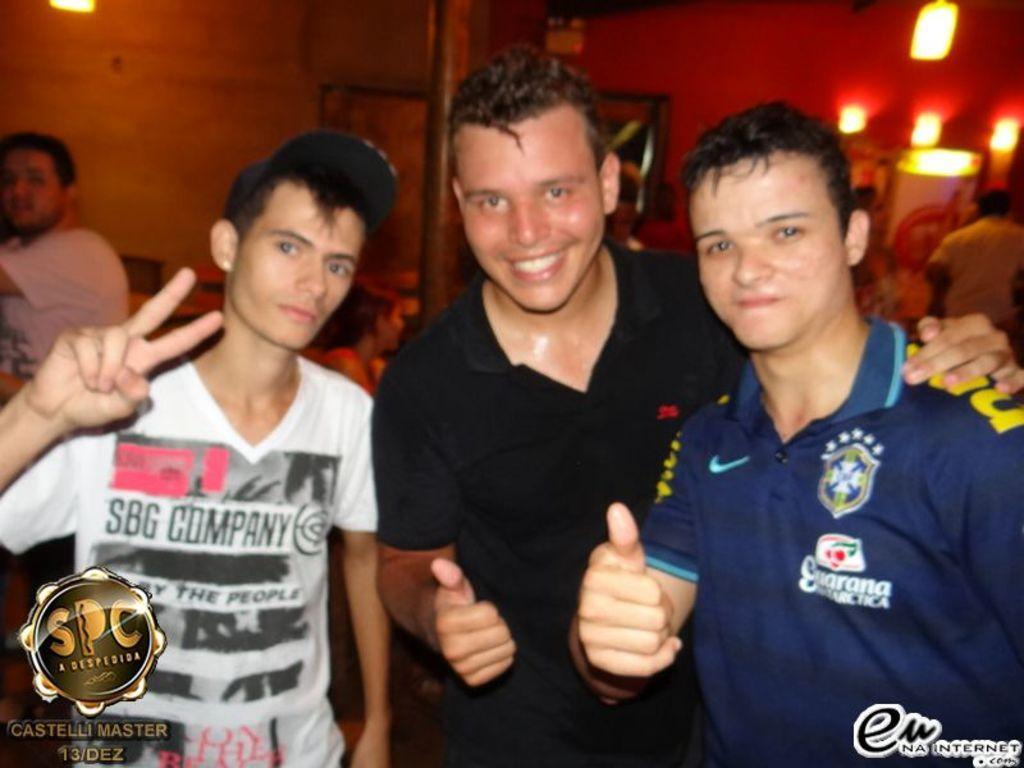Describe this image in one or two sentences. There are three persons standing and smiling. Person on the left is wearing a cap. In the background there are lights. Also there are watermarks in the bottom corners. 